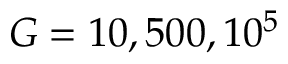Convert formula to latex. <formula><loc_0><loc_0><loc_500><loc_500>G = 1 0 , 5 0 0 , 1 0 ^ { 5 }</formula> 